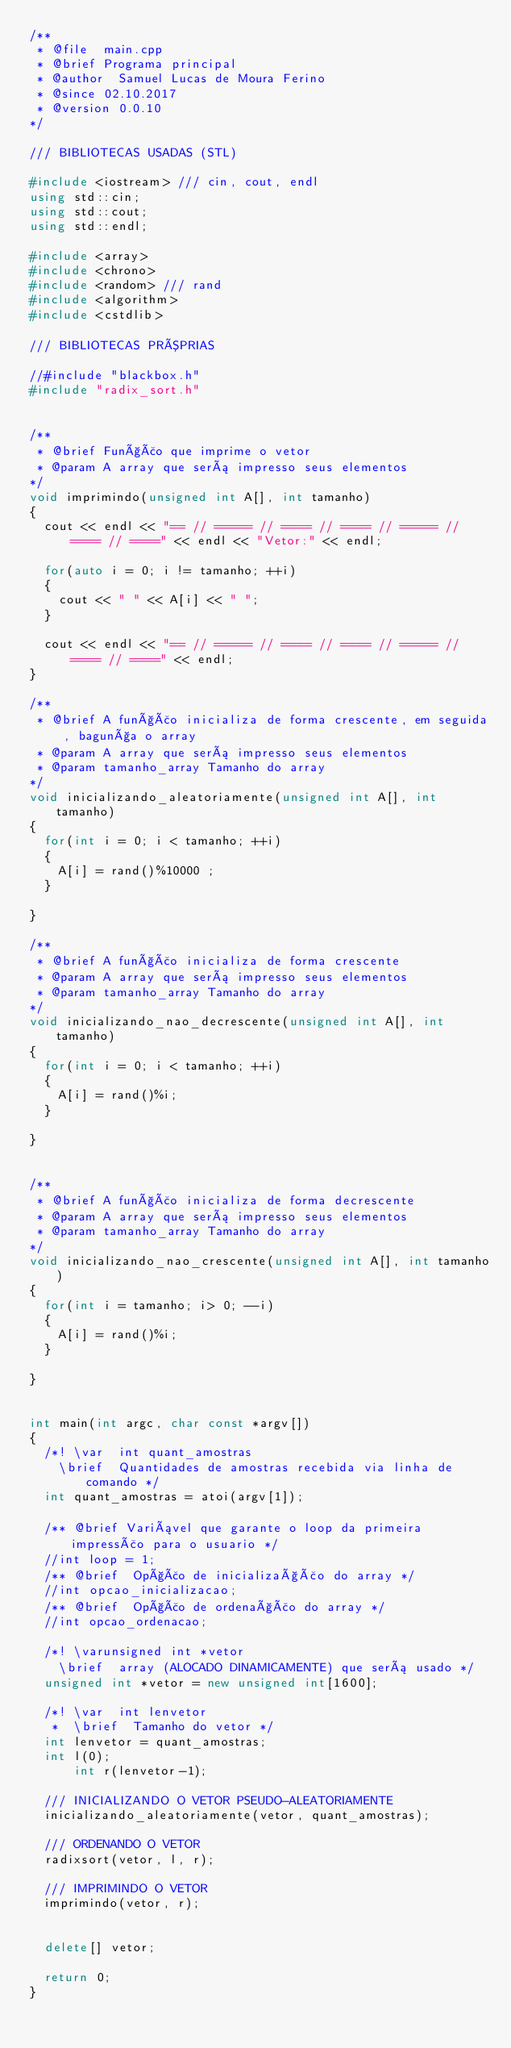Convert code to text. <code><loc_0><loc_0><loc_500><loc_500><_C++_>/**
 * @file	main.cpp
 * @brief	Programa principal
 * @author	Samuel Lucas de Moura Ferino
 * @since	02.10.2017
 * @version	0.0.10
*/

/// BIBLIOTECAS USADAS (STL)

#include <iostream>	/// cin, cout, endl
using std::cin;
using std::cout;
using std::endl;

#include <array>
#include <chrono>
#include <random>	/// rand
#include <algorithm>
#include <cstdlib>

/// BIBLIOTECAS PRÓPRIAS

//#include "blackbox.h"
#include "radix_sort.h"


/** 
 * @brief	Função que imprime o vetor
 * @param	A array que será impresso seus elementos  
*/
void imprimindo(unsigned int A[], int tamanho)
{
	cout << endl << "== // ===== // ==== // ==== // ===== // ==== // ====" << endl << "Vetor:" << endl;
	
	for(auto i = 0; i != tamanho; ++i)
	{
		cout << " " << A[i] << " ";
	}	
	
	cout << endl << "== // ===== // ==== // ==== // ===== // ==== // ====" << endl;
}

/**
 * @brief	A função inicializa de forma crescente, em seguida, bagunça o array
 * @param	A array que será impresso seus elementos
 * @param	tamanho_array Tamanho do array
*/ 
void inicializando_aleatoriamente(unsigned int A[], int tamanho)
{
	for(int i = 0; i < tamanho; ++i)
	{
		A[i] = rand()%10000 ;
	}

}

/**
 * @brief	A função inicializa de forma crescente
 * @param	A array que será impresso seus elementos
 * @param	tamanho_array Tamanho do array
*/ 
void inicializando_nao_decrescente(unsigned int A[], int tamanho)
{
	for(int i = 0; i < tamanho; ++i)
	{
		A[i] = rand()%i;
	}

}


/**
 * @brief	A função inicializa de forma decrescente
 * @param	A array que será impresso seus elementos
 * @param	tamanho_array Tamanho do array
*/ 
void inicializando_nao_crescente(unsigned int A[], int tamanho)
{
	for(int i = tamanho; i> 0; --i)
	{
		A[i] = rand()%i;
	}

}

 
int main(int argc, char const *argv[])
{
	/*! \var	int quant_amostras	
		\brief	Quantidades de amostras recebida via linha de comando */
	int quant_amostras = atoi(argv[1]);
	
	/** @brief Variável que garante o loop da primeira impressão para o usuario */
	//int loop = 1;
	/** @brief	Opção de inicialização do array */
	//int opcao_inicializacao;
	/** @brief	Opção de ordenação do array */
	//int opcao_ordenacao;
	
	/*! \varunsigned int *vetor	 
		\brief	array (ALOCADO DINAMICAMENTE) que será usado */
	unsigned int *vetor = new unsigned int[1600];
	
	/*! \var	int lenvetor
	 * 	\brief	Tamanho do vetor */
	int lenvetor = quant_amostras;
	int l(0);
    	int r(lenvetor-1);
	
	/// INICIALIZANDO O VETOR PSEUDO-ALEATORIAMENTE
	inicializando_aleatoriamente(vetor, quant_amostras);
	
	/// ORDENANDO O VETOR
	radixsort(vetor, l, r);
	
	/// IMPRIMINDO O VETOR
	imprimindo(vetor, r);


	delete[] vetor;
	
	return 0;
}



</code> 